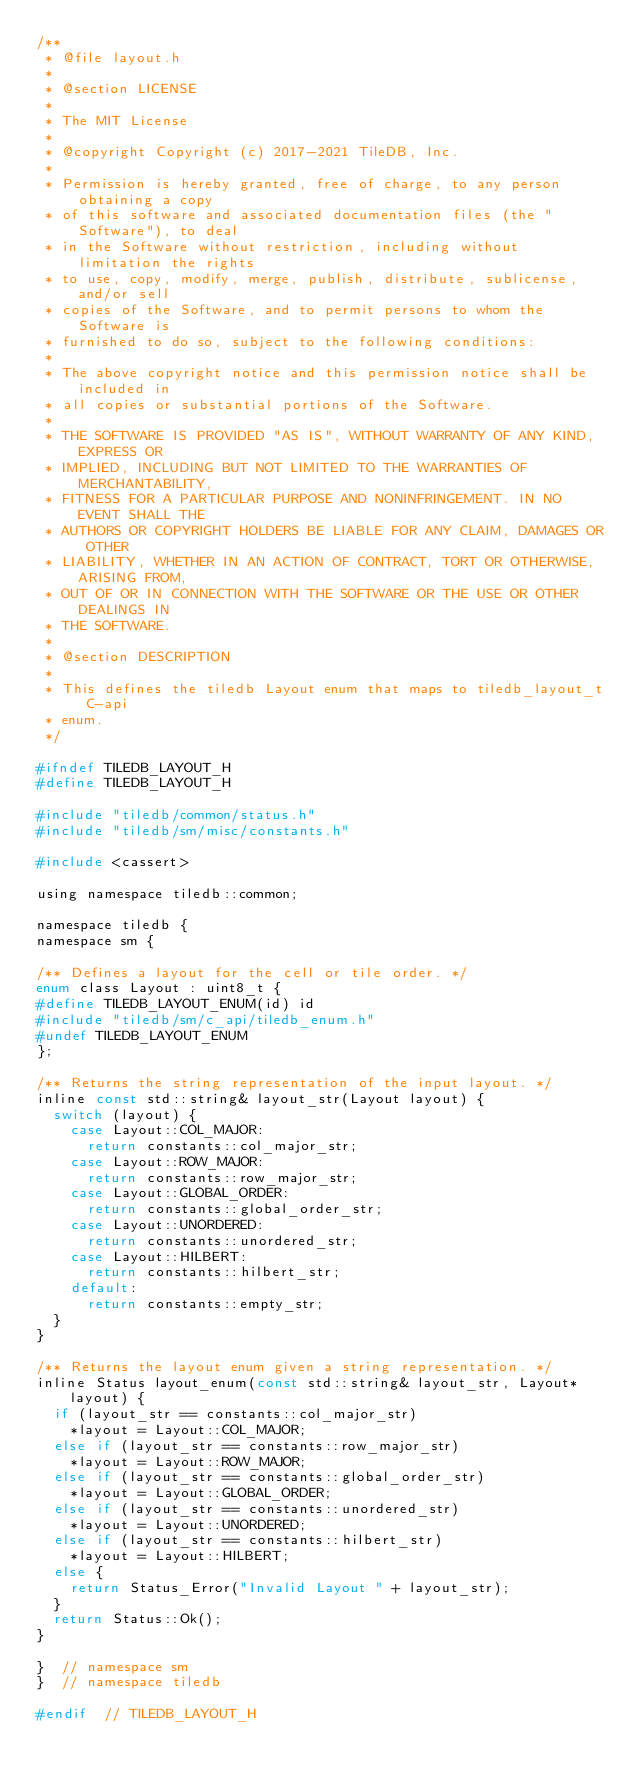Convert code to text. <code><loc_0><loc_0><loc_500><loc_500><_C_>/**
 * @file layout.h
 *
 * @section LICENSE
 *
 * The MIT License
 *
 * @copyright Copyright (c) 2017-2021 TileDB, Inc.
 *
 * Permission is hereby granted, free of charge, to any person obtaining a copy
 * of this software and associated documentation files (the "Software"), to deal
 * in the Software without restriction, including without limitation the rights
 * to use, copy, modify, merge, publish, distribute, sublicense, and/or sell
 * copies of the Software, and to permit persons to whom the Software is
 * furnished to do so, subject to the following conditions:
 *
 * The above copyright notice and this permission notice shall be included in
 * all copies or substantial portions of the Software.
 *
 * THE SOFTWARE IS PROVIDED "AS IS", WITHOUT WARRANTY OF ANY KIND, EXPRESS OR
 * IMPLIED, INCLUDING BUT NOT LIMITED TO THE WARRANTIES OF MERCHANTABILITY,
 * FITNESS FOR A PARTICULAR PURPOSE AND NONINFRINGEMENT. IN NO EVENT SHALL THE
 * AUTHORS OR COPYRIGHT HOLDERS BE LIABLE FOR ANY CLAIM, DAMAGES OR OTHER
 * LIABILITY, WHETHER IN AN ACTION OF CONTRACT, TORT OR OTHERWISE, ARISING FROM,
 * OUT OF OR IN CONNECTION WITH THE SOFTWARE OR THE USE OR OTHER DEALINGS IN
 * THE SOFTWARE.
 *
 * @section DESCRIPTION
 *
 * This defines the tiledb Layout enum that maps to tiledb_layout_t C-api
 * enum.
 */

#ifndef TILEDB_LAYOUT_H
#define TILEDB_LAYOUT_H

#include "tiledb/common/status.h"
#include "tiledb/sm/misc/constants.h"

#include <cassert>

using namespace tiledb::common;

namespace tiledb {
namespace sm {

/** Defines a layout for the cell or tile order. */
enum class Layout : uint8_t {
#define TILEDB_LAYOUT_ENUM(id) id
#include "tiledb/sm/c_api/tiledb_enum.h"
#undef TILEDB_LAYOUT_ENUM
};

/** Returns the string representation of the input layout. */
inline const std::string& layout_str(Layout layout) {
  switch (layout) {
    case Layout::COL_MAJOR:
      return constants::col_major_str;
    case Layout::ROW_MAJOR:
      return constants::row_major_str;
    case Layout::GLOBAL_ORDER:
      return constants::global_order_str;
    case Layout::UNORDERED:
      return constants::unordered_str;
    case Layout::HILBERT:
      return constants::hilbert_str;
    default:
      return constants::empty_str;
  }
}

/** Returns the layout enum given a string representation. */
inline Status layout_enum(const std::string& layout_str, Layout* layout) {
  if (layout_str == constants::col_major_str)
    *layout = Layout::COL_MAJOR;
  else if (layout_str == constants::row_major_str)
    *layout = Layout::ROW_MAJOR;
  else if (layout_str == constants::global_order_str)
    *layout = Layout::GLOBAL_ORDER;
  else if (layout_str == constants::unordered_str)
    *layout = Layout::UNORDERED;
  else if (layout_str == constants::hilbert_str)
    *layout = Layout::HILBERT;
  else {
    return Status_Error("Invalid Layout " + layout_str);
  }
  return Status::Ok();
}

}  // namespace sm
}  // namespace tiledb

#endif  // TILEDB_LAYOUT_H
</code> 